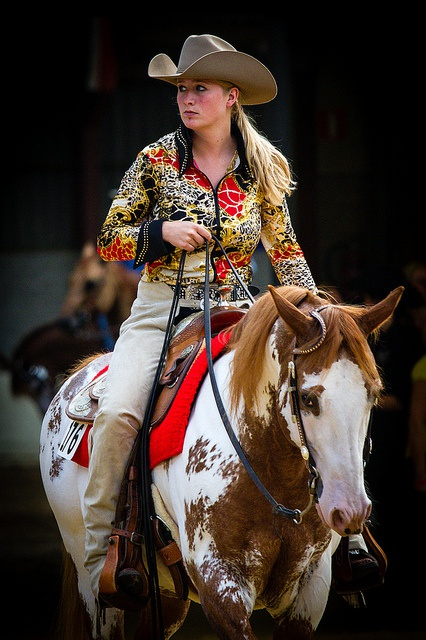Describe the objects in this image and their specific colors. I can see horse in black, maroon, lightgray, and darkgray tones and people in black, lightgray, darkgray, and gray tones in this image. 